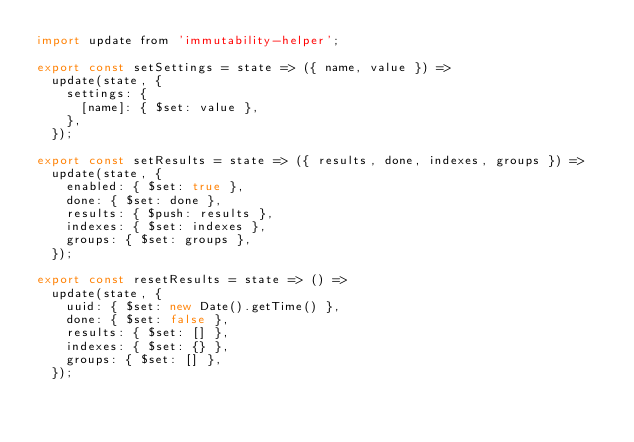Convert code to text. <code><loc_0><loc_0><loc_500><loc_500><_JavaScript_>import update from 'immutability-helper';

export const setSettings = state => ({ name, value }) =>
  update(state, {
    settings: {
      [name]: { $set: value },
    },
  });

export const setResults = state => ({ results, done, indexes, groups }) =>
  update(state, {
    enabled: { $set: true },
    done: { $set: done },
    results: { $push: results },
    indexes: { $set: indexes },
    groups: { $set: groups },
  });

export const resetResults = state => () =>
  update(state, {
    uuid: { $set: new Date().getTime() },
    done: { $set: false },
    results: { $set: [] },
    indexes: { $set: {} },
    groups: { $set: [] },
  });
</code> 